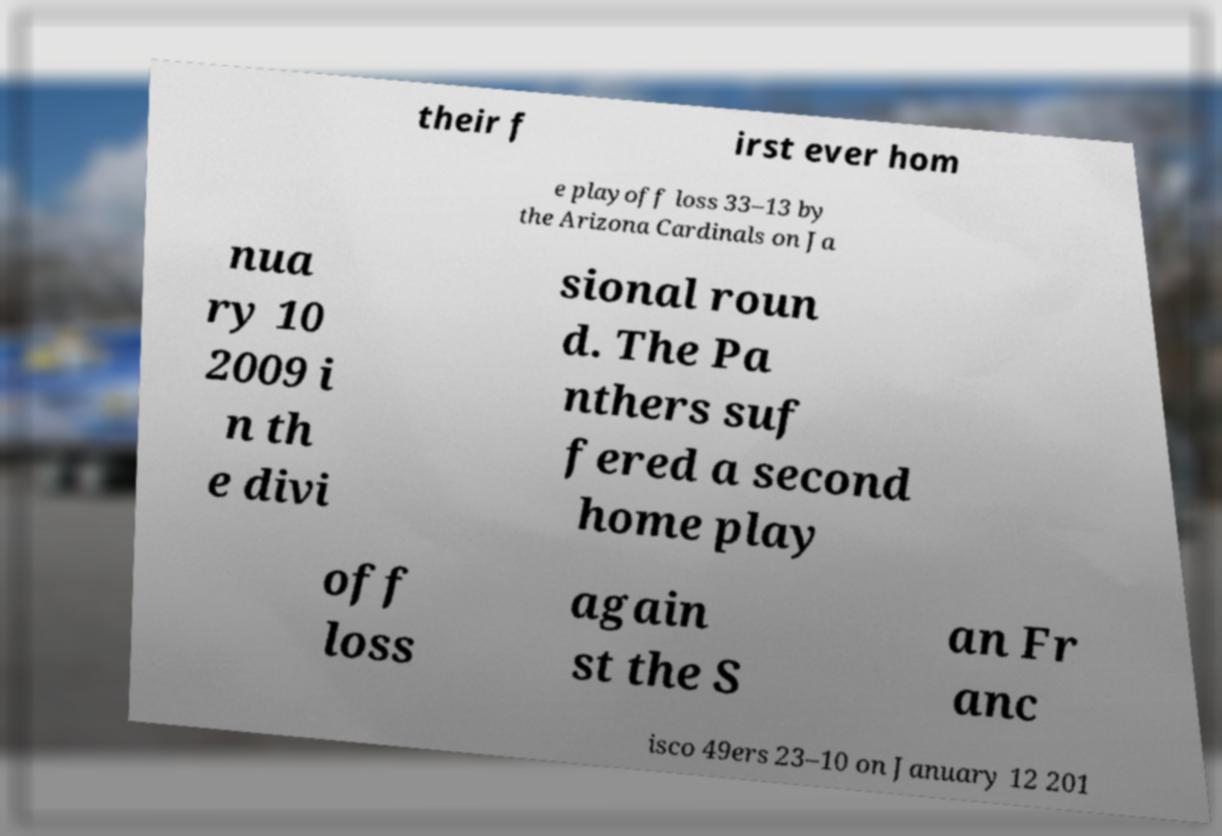What messages or text are displayed in this image? I need them in a readable, typed format. their f irst ever hom e playoff loss 33–13 by the Arizona Cardinals on Ja nua ry 10 2009 i n th e divi sional roun d. The Pa nthers suf fered a second home play off loss again st the S an Fr anc isco 49ers 23–10 on January 12 201 